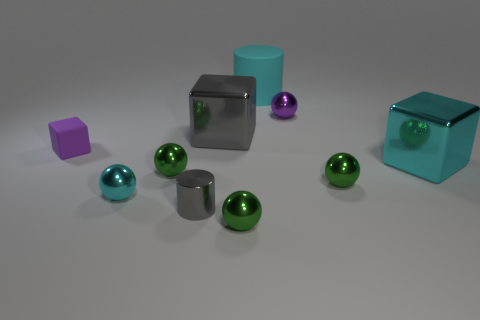Subtract all gray cylinders. How many green spheres are left? 3 Subtract all cyan spheres. How many spheres are left? 4 Subtract all cyan spheres. How many spheres are left? 4 Subtract all yellow spheres. Subtract all green cylinders. How many spheres are left? 5 Subtract all cubes. How many objects are left? 7 Subtract all tiny green spheres. Subtract all large gray things. How many objects are left? 6 Add 4 green metal objects. How many green metal objects are left? 7 Add 9 tiny blocks. How many tiny blocks exist? 10 Subtract 1 cyan balls. How many objects are left? 9 